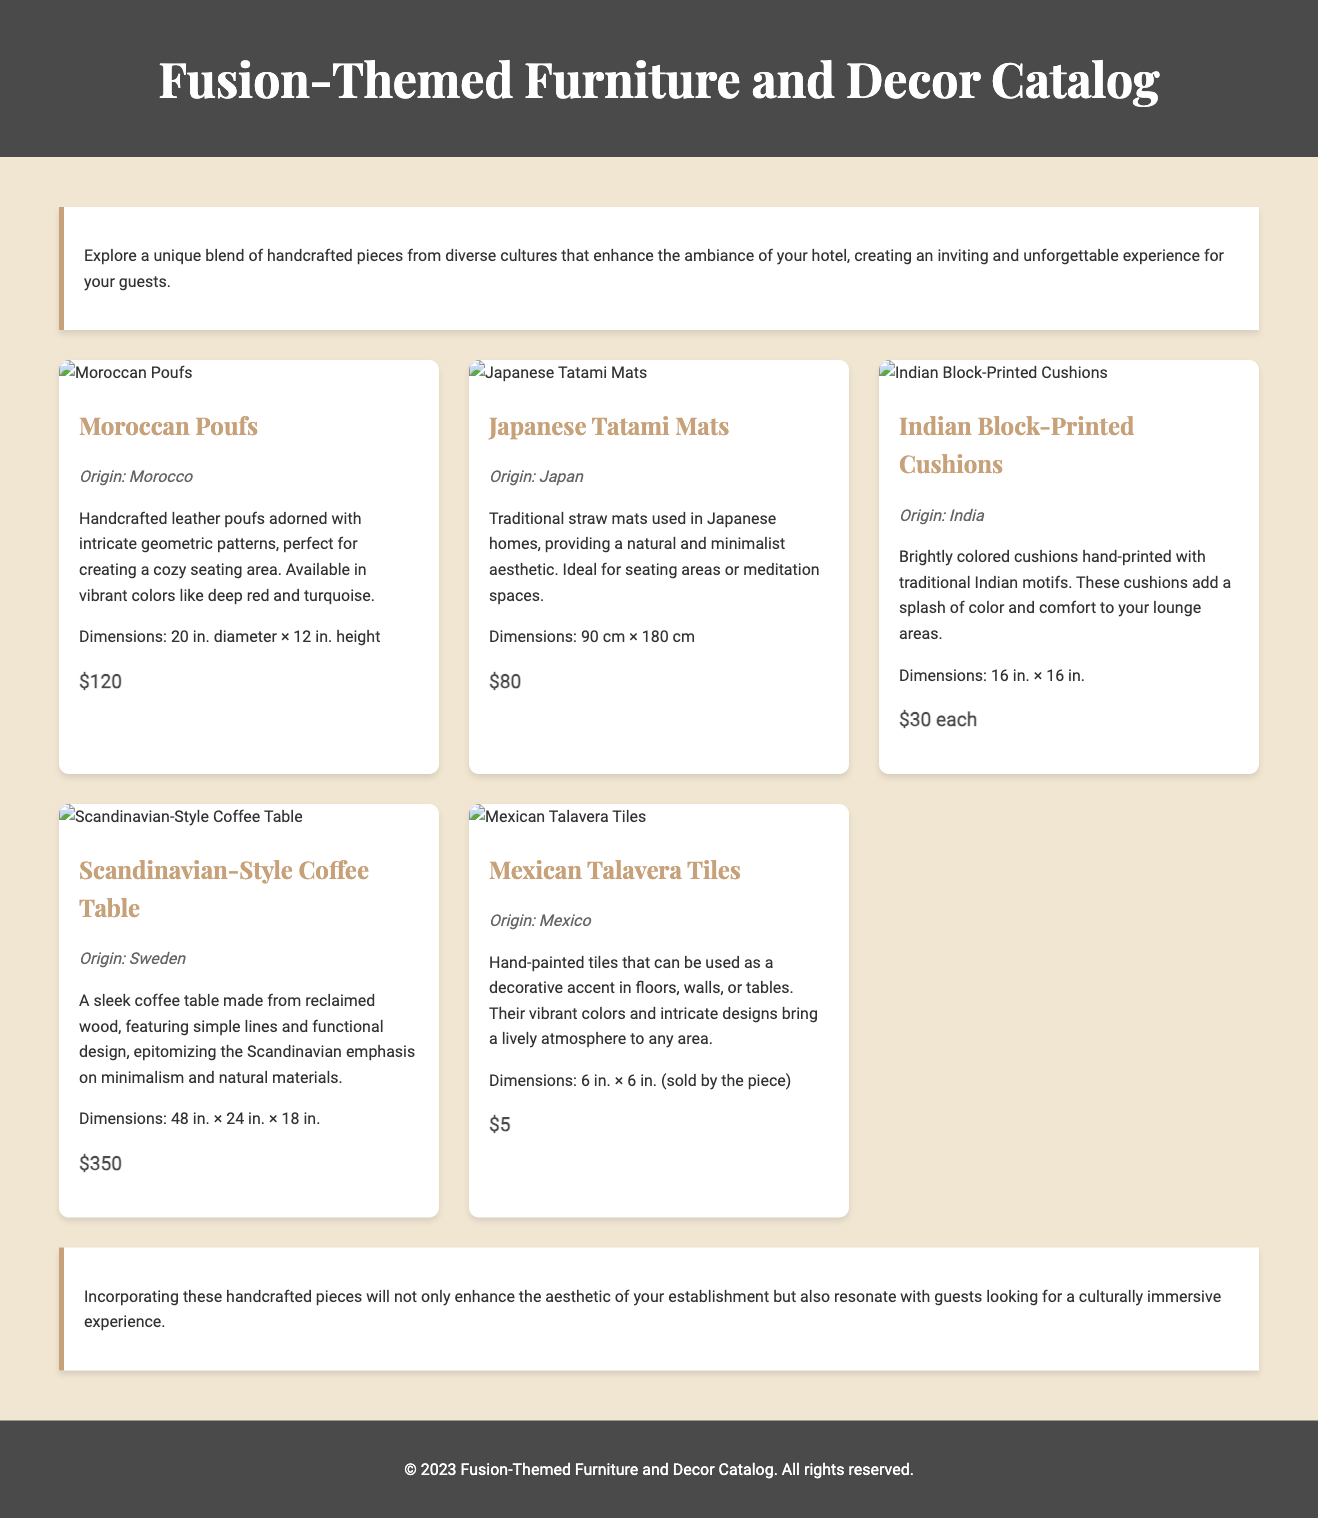What is the price of Moroccan Poufs? The price of Moroccan Poufs is listed in the document as $120.
Answer: $120 What is the origin of Japanese Tatami Mats? The document specifies that Japanese Tatami Mats originate from Japan.
Answer: Japan How many cushions are mentioned in the Indian Block-Printed Cushions? The document indicates that the Indian Block-Printed Cushions are sold "each," implying individual cushions, whether or not it's a set is not stated.
Answer: each What is the total price for one Mexican Talavera Tile? According to the document, one Mexican Talavera Tile costs $5.
Answer: $5 What are the dimensions of the Scandinavian-Style Coffee Table? The dimensions of the Scandinavian-Style Coffee Table are provided as 48 in. × 24 in. × 18 in. in the document.
Answer: 48 in. × 24 in. × 18 in What unique feature do Mexican Talavera Tiles have? The document describes Mexican Talavera Tiles as "hand-painted," highlighting their decorative quality.
Answer: hand-painted Which item features intricate geometric patterns? The Moroccan Poufs are noted in the document to be adorned with intricate geometric patterns.
Answer: Moroccan Poufs What is emphasized by the design of the Scandinavian-Style Coffee Table? The document states that the Scandinavian-Style Coffee Table embodies "minimalism and natural materials."
Answer: minimalism and natural materials 